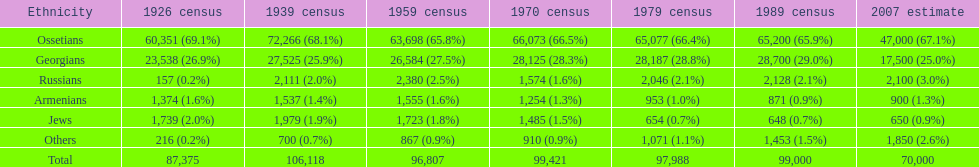What was the first census that saw a russian population of over 2,000? 1939 census. 